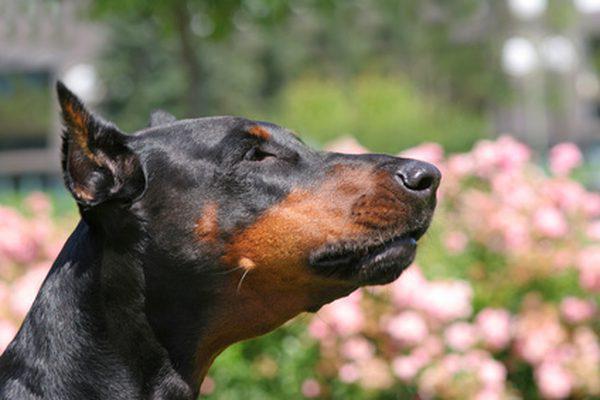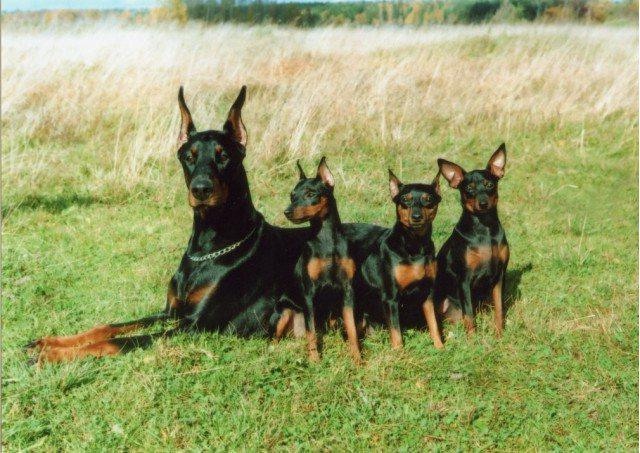The first image is the image on the left, the second image is the image on the right. Analyze the images presented: Is the assertion "The left image contains one rightward-gazing doberman with erect ears, and the right image features a reclining doberman accompanied by at least three other dogs." valid? Answer yes or no. Yes. 